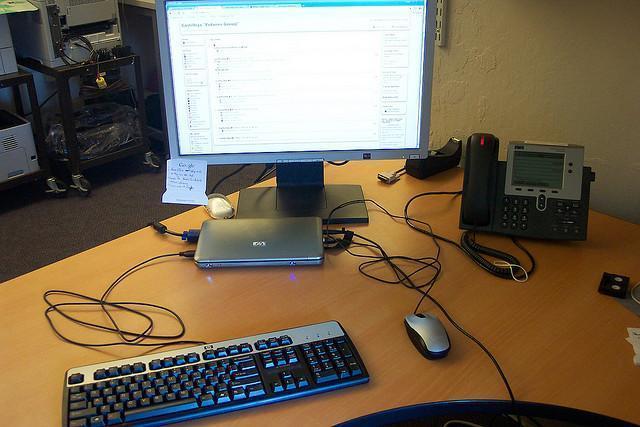How many people are in the shot?
Give a very brief answer. 0. 